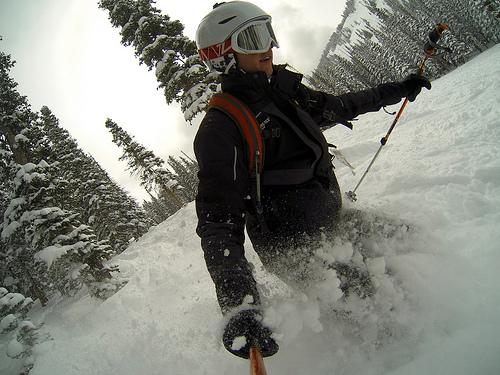Provide a short and concise description of the scene in the image. A person skiing in the snow with a white helmet, goggles, and a black jacket, while surrounded by snow covered pine trees. Mention the action being performed by the main subject in the image and their surroundings. A person is skiing through snow near pine trees, wearing a helmet, goggles, and a black jacket. Give a description of the person in the image, including the type of actions they are performing. A person wearing a helmet and goggles is skiing, holding onto ski poles and kicking up snow in their path. List the primary elements in the image, including the person's attire and surroundings. Skier with white helmet, goggles, black jacket, pine trees, ski poles, airborne snow, backpack strap, and winter gloves. Mention the key features and elements in the image, emphasizing the person and their environment. White helmet, goggles, black jacket skier amidst snow-covered pine trees, with ski poles, airborne snow, and a red bag strap. Illustrate the main subject's attire and their immediate environment in the image. A skier in a white helmet, goggles, and a black jacket is surrounded by airborne snow and snow-covered pine trees. Describe the skier's appearance and their interactions with the snowy environment. A person wearing a white helmet, goggles, and a black jacket is skiing through the snow, kicking it up into the air. Explain the visuals occurring in the image, focusing on the main subject and their attire. A person wearing a white helmet, goggles, and a black jacket is skiing, reflected by the presence of ski poles and airborne snow. Write a brief sentence describing the individual and how they appear in the image. A skier is wearing a white helmet, goggles, and a black jacket while in motion amid snow-covered trees. Explain the weather conditions in the image and the state of the main subject. A skier with a white helmet and goggles is making tracks in grey and cloudy weather with snow in the air. 